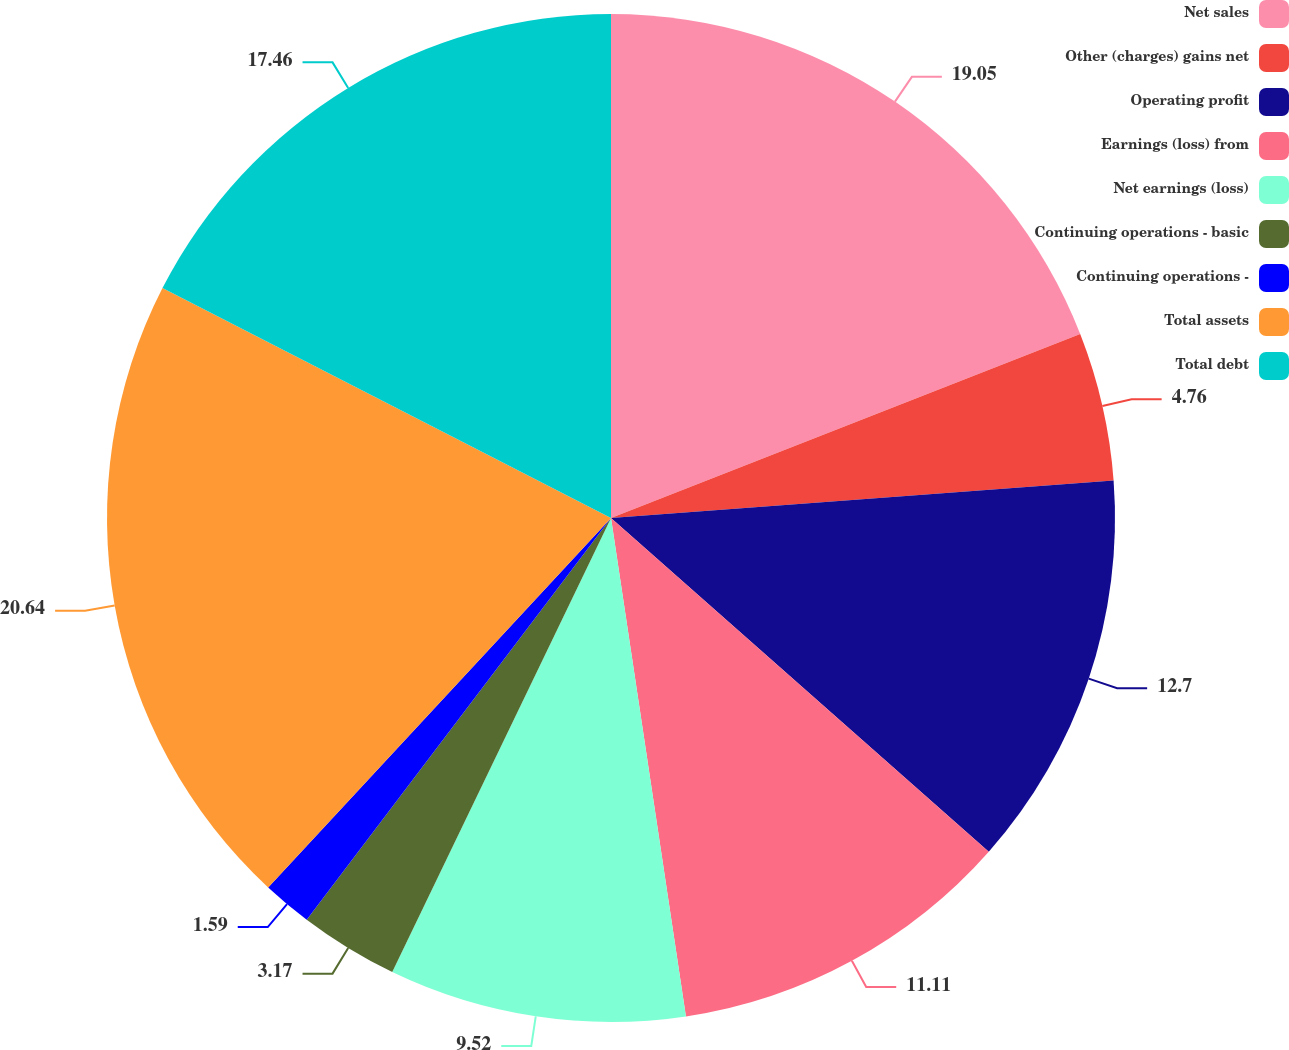Convert chart to OTSL. <chart><loc_0><loc_0><loc_500><loc_500><pie_chart><fcel>Net sales<fcel>Other (charges) gains net<fcel>Operating profit<fcel>Earnings (loss) from<fcel>Net earnings (loss)<fcel>Continuing operations - basic<fcel>Continuing operations -<fcel>Total assets<fcel>Total debt<nl><fcel>19.05%<fcel>4.76%<fcel>12.7%<fcel>11.11%<fcel>9.52%<fcel>3.17%<fcel>1.59%<fcel>20.63%<fcel>17.46%<nl></chart> 